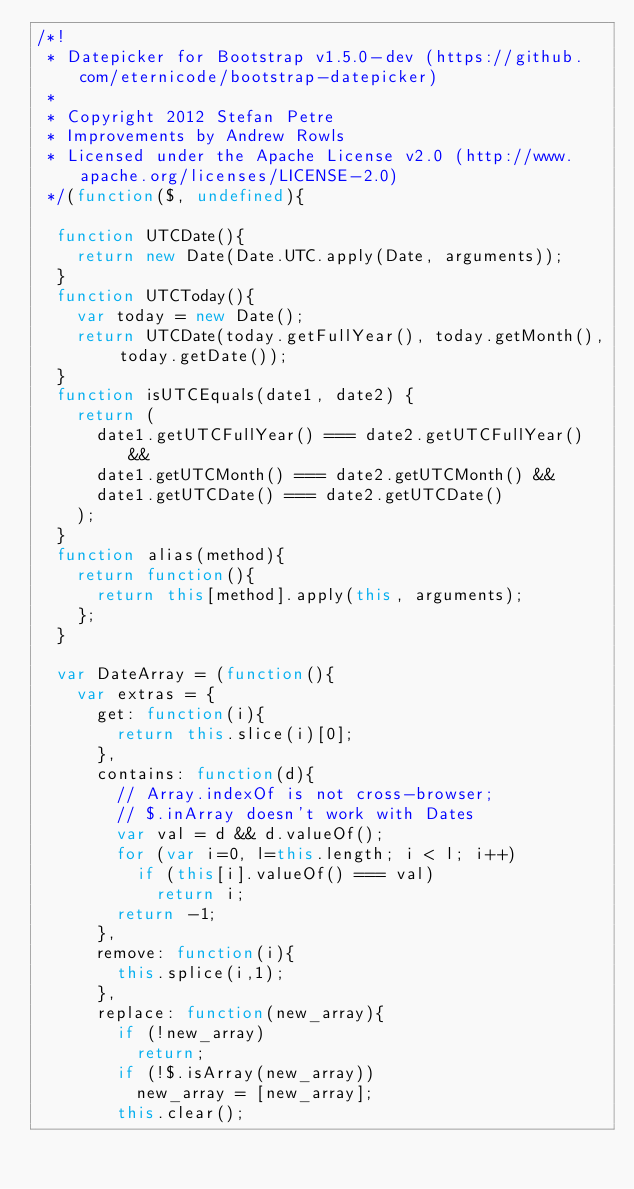<code> <loc_0><loc_0><loc_500><loc_500><_JavaScript_>/*!
 * Datepicker for Bootstrap v1.5.0-dev (https://github.com/eternicode/bootstrap-datepicker)
 *
 * Copyright 2012 Stefan Petre
 * Improvements by Andrew Rowls
 * Licensed under the Apache License v2.0 (http://www.apache.org/licenses/LICENSE-2.0)
 */(function($, undefined){

	function UTCDate(){
		return new Date(Date.UTC.apply(Date, arguments));
	}
	function UTCToday(){
		var today = new Date();
		return UTCDate(today.getFullYear(), today.getMonth(), today.getDate());
	}
	function isUTCEquals(date1, date2) {
		return (
			date1.getUTCFullYear() === date2.getUTCFullYear() &&
			date1.getUTCMonth() === date2.getUTCMonth() &&
			date1.getUTCDate() === date2.getUTCDate()
		);
	}
	function alias(method){
		return function(){
			return this[method].apply(this, arguments);
		};
	}

	var DateArray = (function(){
		var extras = {
			get: function(i){
				return this.slice(i)[0];
			},
			contains: function(d){
				// Array.indexOf is not cross-browser;
				// $.inArray doesn't work with Dates
				var val = d && d.valueOf();
				for (var i=0, l=this.length; i < l; i++)
					if (this[i].valueOf() === val)
						return i;
				return -1;
			},
			remove: function(i){
				this.splice(i,1);
			},
			replace: function(new_array){
				if (!new_array)
					return;
				if (!$.isArray(new_array))
					new_array = [new_array];
				this.clear();</code> 